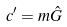Convert formula to latex. <formula><loc_0><loc_0><loc_500><loc_500>c ^ { \prime } = m \hat { G }</formula> 